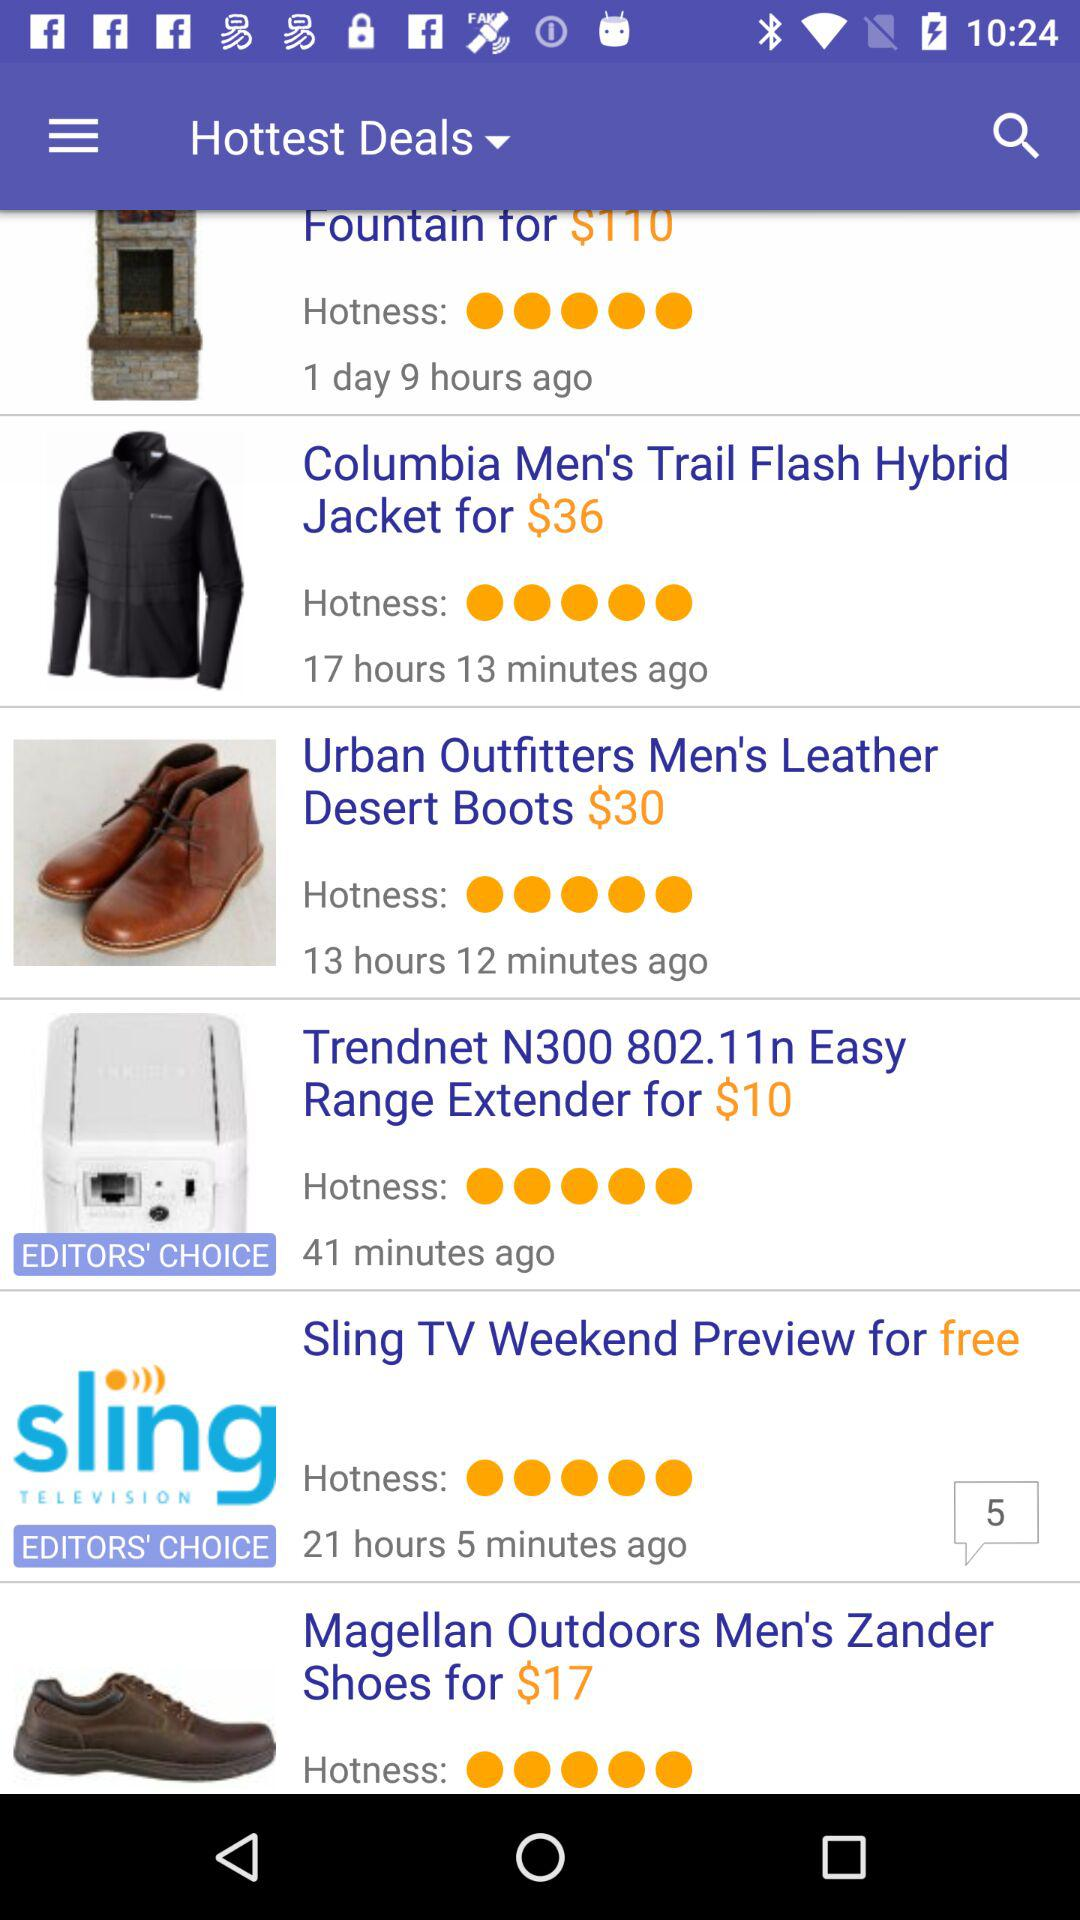What is the price of the hottest deal on the "Columbia Men's Trail Flash Hybrid Jacket"? The price of the hottest deal on the "Columbia Men's Trail Flash Hybrid Jacket" is $36. 